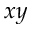Convert formula to latex. <formula><loc_0><loc_0><loc_500><loc_500>x y</formula> 